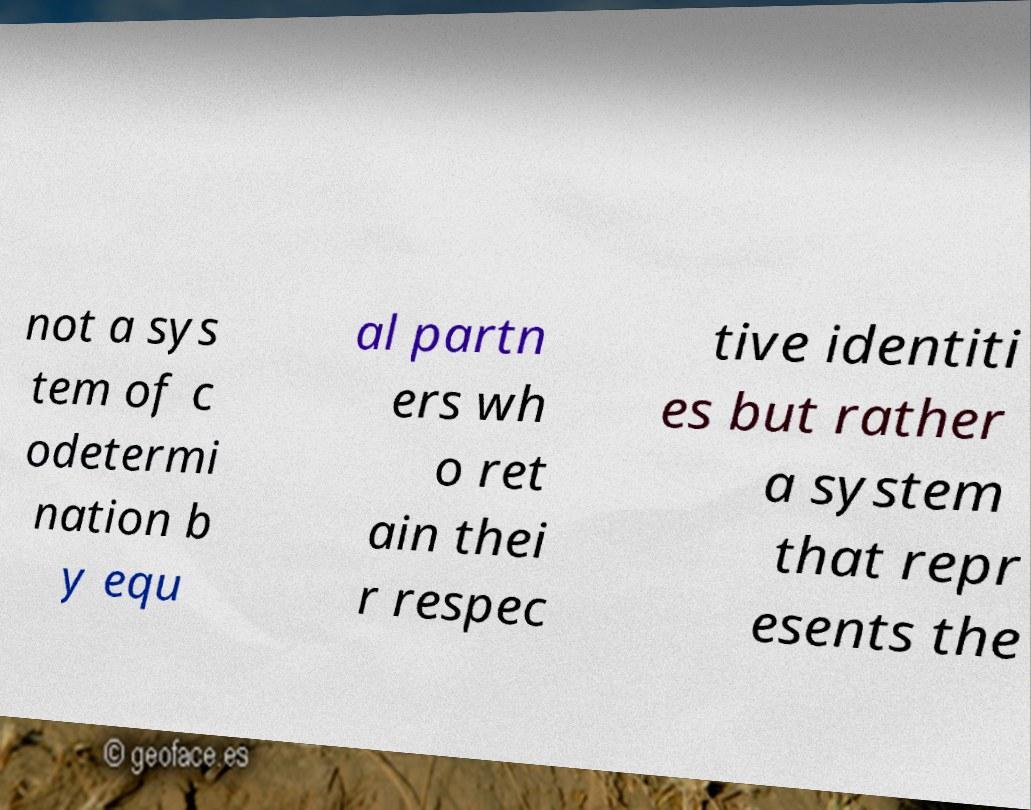Can you read and provide the text displayed in the image?This photo seems to have some interesting text. Can you extract and type it out for me? not a sys tem of c odetermi nation b y equ al partn ers wh o ret ain thei r respec tive identiti es but rather a system that repr esents the 